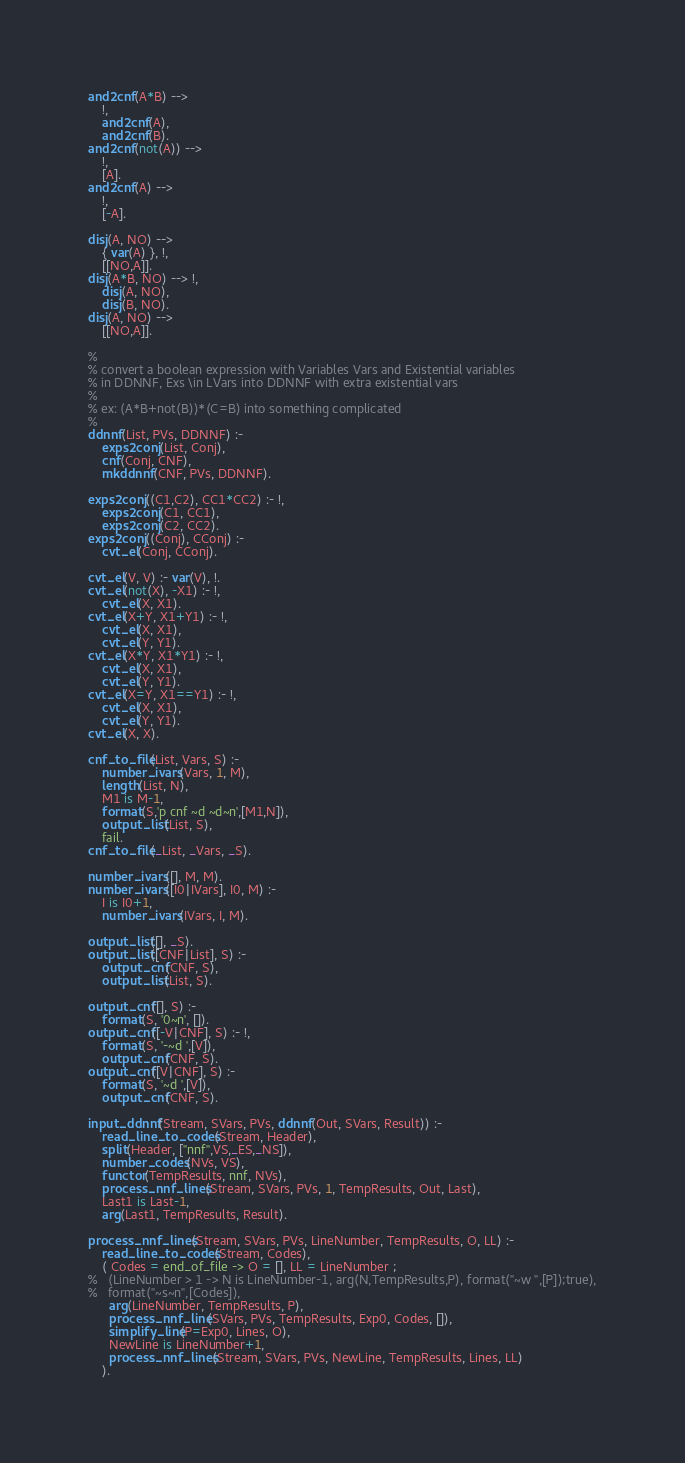Convert code to text. <code><loc_0><loc_0><loc_500><loc_500><_Prolog_>and2cnf(A*B) -->
	!,
	and2cnf(A),
	and2cnf(B).
and2cnf(not(A)) -->
	!,
	[A].
and2cnf(A) -->
	!,
	[-A].

disj(A, NO) --> 
	{ var(A) }, !,
	[[NO,A]].
disj(A*B, NO) --> !,
	disj(A, NO),
	disj(B, NO).
disj(A, NO) -->
	[[NO,A]].

%
% convert a boolean expression with Variables Vars and Existential variables
% in DDNNF, Exs \in LVars into DDNNF with extra existential vars
%
% ex: (A*B+not(B))*(C=B) into something complicated 
%
ddnnf(List, PVs, DDNNF) :-
	exps2conj(List, Conj),
	cnf(Conj, CNF),
	mkddnnf(CNF, PVs, DDNNF).

exps2conj((C1,C2), CC1*CC2) :- !,
	exps2conj(C1, CC1),
	exps2conj(C2, CC2).
exps2conj((Conj), CConj) :- 
	cvt_el(Conj, CConj).

cvt_el(V, V) :- var(V), !.
cvt_el(not(X), -X1) :- !,
	cvt_el(X, X1).
cvt_el(X+Y, X1+Y1) :- !,
	cvt_el(X, X1),
	cvt_el(Y, Y1).
cvt_el(X*Y, X1*Y1) :- !,
	cvt_el(X, X1),
	cvt_el(Y, Y1).
cvt_el(X=Y, X1==Y1) :- !,
	cvt_el(X, X1),
	cvt_el(Y, Y1).
cvt_el(X, X).

cnf_to_file(List, Vars, S) :-
	number_ivars(Vars, 1, M),
	length(List, N),
	M1 is M-1,
	format(S,'p cnf ~d ~d~n',[M1,N]),
	output_list(List, S),
	fail.
cnf_to_file(_List, _Vars, _S).

number_ivars([], M, M).
number_ivars([I0|IVars], I0, M) :-
	I is I0+1,
	number_ivars(IVars, I, M).

output_list([], _S).
output_list([CNF|List], S) :-
	output_cnf(CNF, S),
	output_list(List, S).

output_cnf([], S) :-
	format(S, '0~n', []).
output_cnf([-V|CNF], S) :- !,
	format(S, '-~d ',[V]),
	output_cnf(CNF, S).
output_cnf([V|CNF], S) :-
	format(S, '~d ',[V]),
	output_cnf(CNF, S).

input_ddnnf(Stream, SVars, PVs, ddnnf(Out, SVars, Result)) :-
	read_line_to_codes(Stream, Header),
	split(Header, ["nnf",VS,_ES,_NS]),
	number_codes(NVs, VS),
	functor(TempResults, nnf, NVs),
	process_nnf_lines(Stream, SVars, PVs, 1, TempResults, Out, Last),
	Last1 is Last-1,
	arg(Last1, TempResults, Result).
	
process_nnf_lines(Stream, SVars, PVs, LineNumber, TempResults, O, LL) :-
	read_line_to_codes(Stream, Codes),
	( Codes = end_of_file -> O = [], LL = LineNumber ;
%	(LineNumber > 1 -> N is LineNumber-1, arg(N,TempResults,P), format("~w ",[P]);true),
%	format("~s~n",[Codes]),
	  arg(LineNumber, TempResults, P),
	  process_nnf_line(SVars, PVs, TempResults, Exp0, Codes, []),
	  simplify_line(P=Exp0, Lines, O),
	  NewLine is LineNumber+1,
	  process_nnf_lines(Stream, SVars, PVs, NewLine, TempResults, Lines, LL)
	).
</code> 